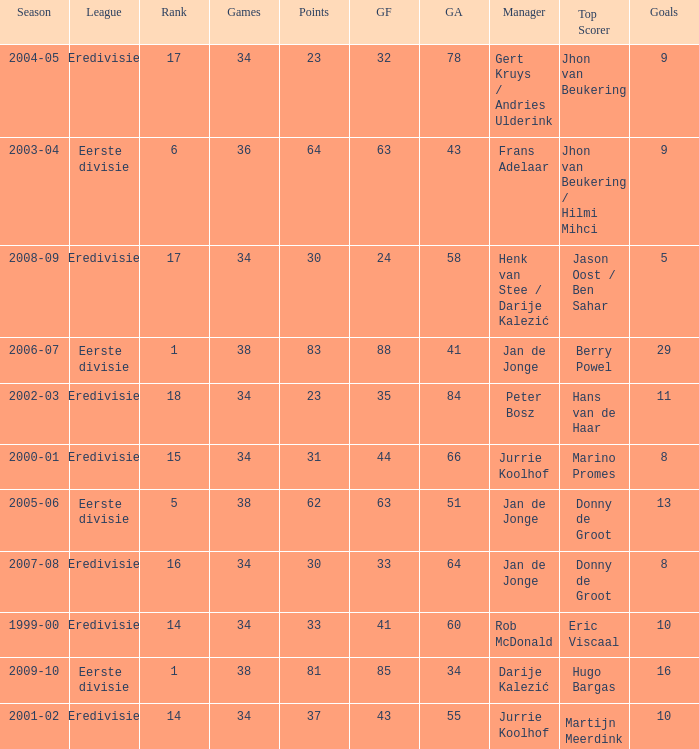Who is the manager whose rank is 16? Jan de Jonge. 